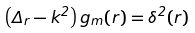<formula> <loc_0><loc_0><loc_500><loc_500>\left ( \Delta _ { r } - k ^ { 2 } \right ) g _ { m } ( { r } ) = \delta ^ { 2 } ( { r } )</formula> 